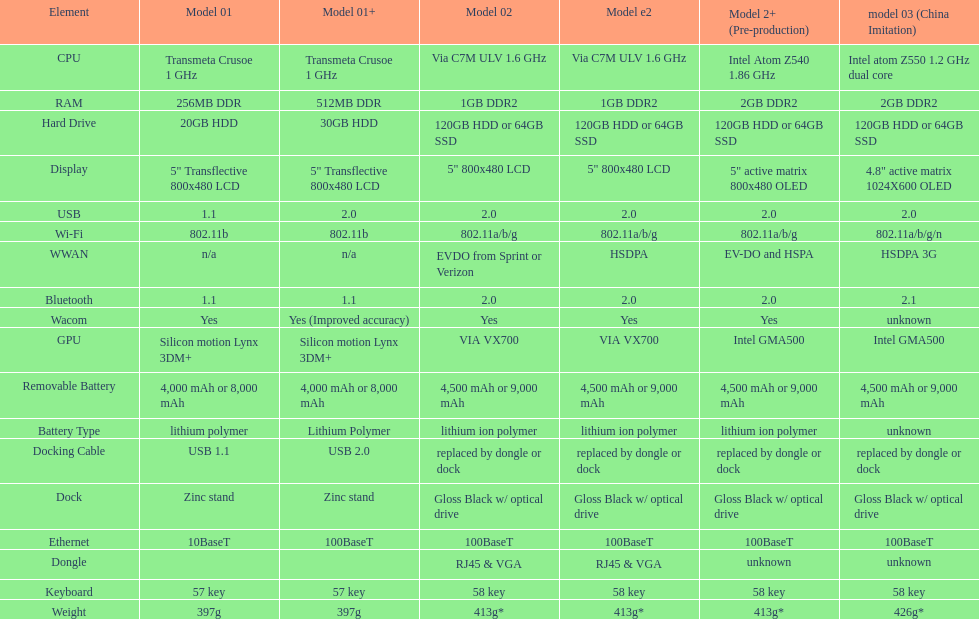What component comes after bluetooth? Wacom. 